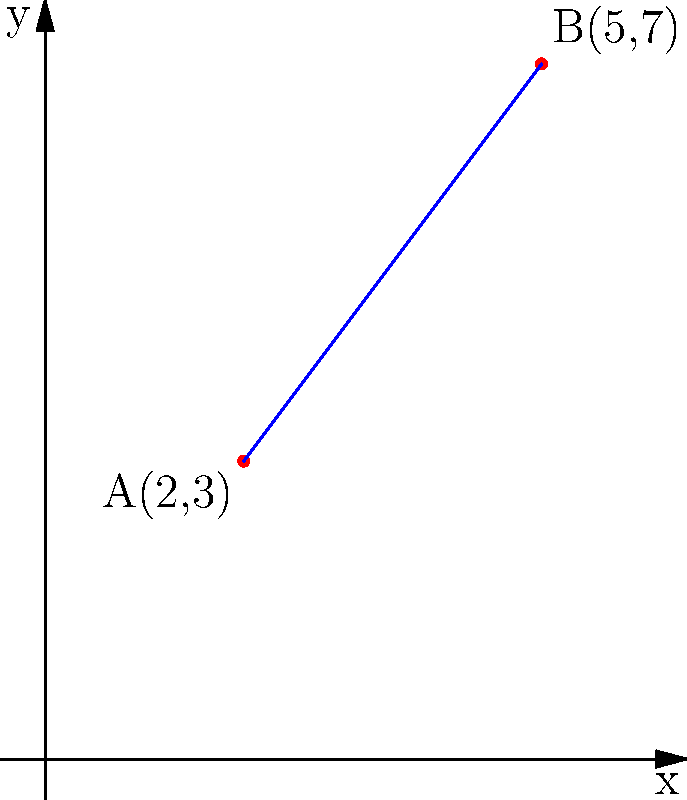In a hospital layout, two medication dispensing stations are located at coordinates A(2,3) and B(5,7). As a nurse manager implementing an electronic health record system, you need to determine the equation of the line passing through these two stations for efficient medication tracking. What is the equation of this line in slope-intercept form $(y = mx + b)$? To find the equation of the line passing through two points, we'll follow these steps:

1. Calculate the slope $(m)$ using the slope formula:
   $m = \frac{y_2 - y_1}{x_2 - x_1} = \frac{7 - 3}{5 - 2} = \frac{4}{3}$

2. Use the point-slope form of a line equation:
   $y - y_1 = m(x - x_1)$

3. Choose either point A(2,3) or B(5,7). Let's use A(2,3):
   $y - 3 = \frac{4}{3}(x - 2)$

4. Expand the equation:
   $y - 3 = \frac{4}{3}x - \frac{8}{3}$

5. Solve for $y$ to get the slope-intercept form:
   $y = \frac{4}{3}x - \frac{8}{3} + 3$
   $y = \frac{4}{3}x + \frac{1}{3}$

Therefore, the equation of the line passing through the two medication dispensing stations in slope-intercept form is $y = \frac{4}{3}x + \frac{1}{3}$.
Answer: $y = \frac{4}{3}x + \frac{1}{3}$ 